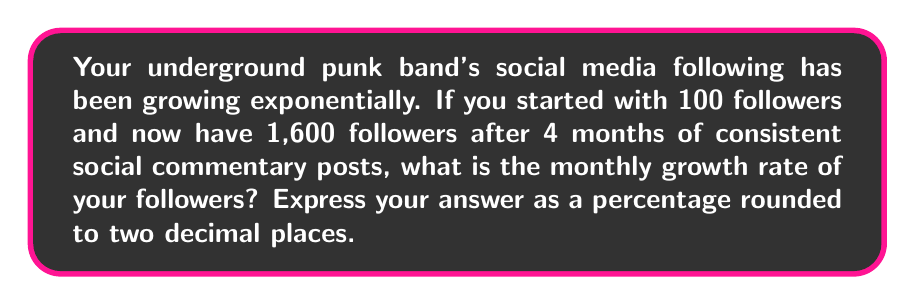Show me your answer to this math problem. Let's approach this step-by-step using the exponential growth formula:

$A = P(1 + r)^t$

Where:
$A$ = Final amount (1,600 followers)
$P$ = Initial amount (100 followers)
$r$ = Growth rate (what we're solving for)
$t$ = Time period (4 months)

1) Substitute the known values into the formula:
   $1600 = 100(1 + r)^4$

2) Divide both sides by 100:
   $16 = (1 + r)^4$

3) Take the fourth root of both sides:
   $\sqrt[4]{16} = 1 + r$

4) Simplify:
   $2 = 1 + r$

5) Subtract 1 from both sides:
   $1 = r$

6) Convert to a percentage:
   $r = 1 * 100\% = 100\%$

Therefore, the monthly growth rate is 100%.
Answer: 100% 